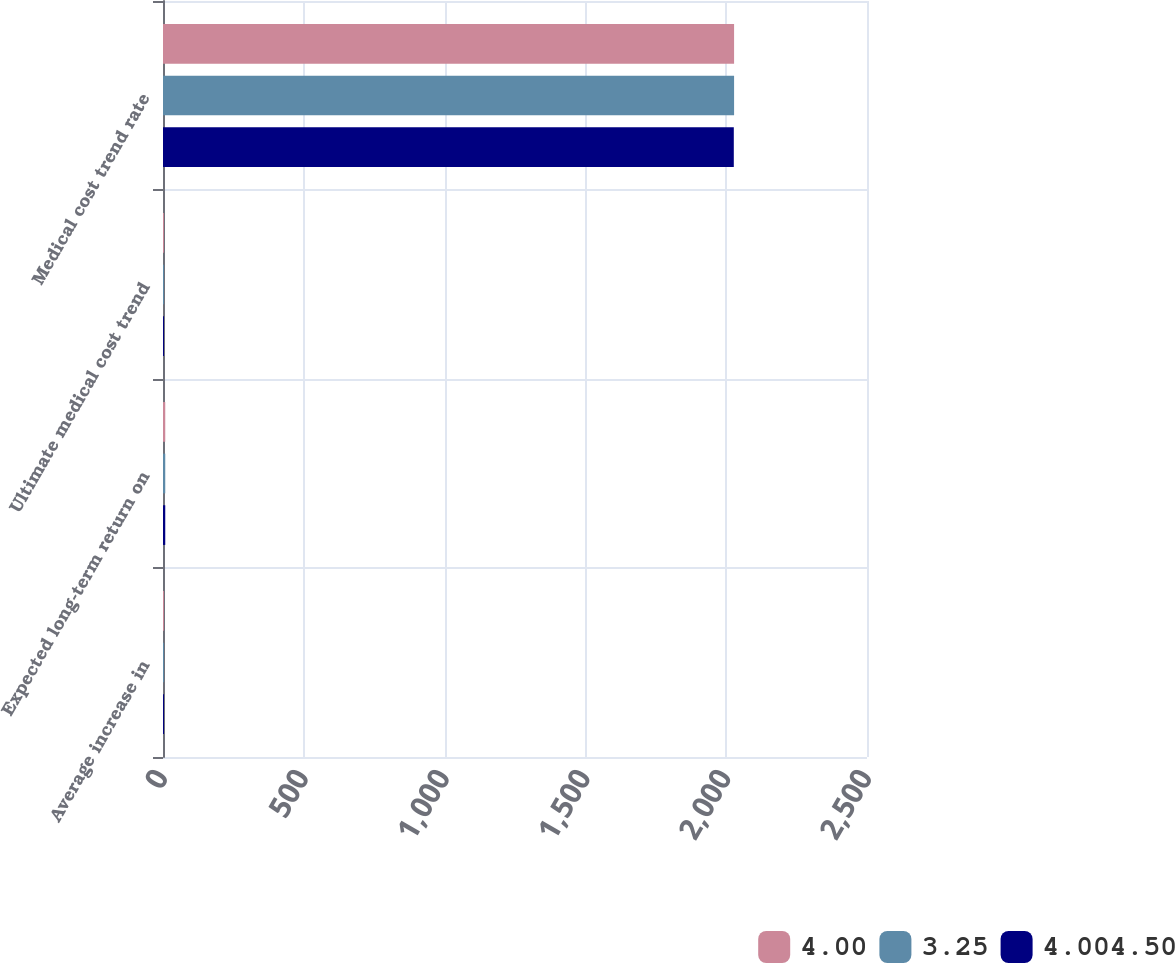Convert chart to OTSL. <chart><loc_0><loc_0><loc_500><loc_500><stacked_bar_chart><ecel><fcel>Average increase in<fcel>Expected long-term return on<fcel>Ultimate medical cost trend<fcel>Medical cost trend rate<nl><fcel>4.00<fcel>3.5<fcel>8<fcel>3.5<fcel>2028<nl><fcel>3.25<fcel>3.5<fcel>8<fcel>3.5<fcel>2028<nl><fcel>4.004.50<fcel>3.5<fcel>8<fcel>3.5<fcel>2027<nl></chart> 